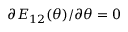<formula> <loc_0><loc_0><loc_500><loc_500>\partial E _ { 1 2 } ( \theta ) / \partial \theta = 0</formula> 